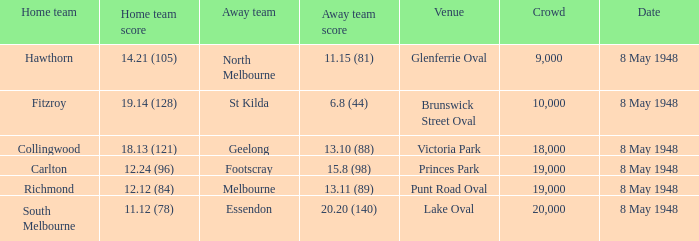What was the number of viewers present at the match when the visiting team scored 1 19000.0. 